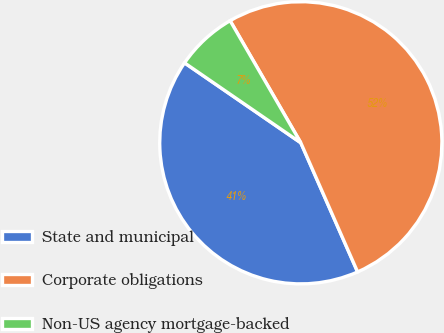Convert chart to OTSL. <chart><loc_0><loc_0><loc_500><loc_500><pie_chart><fcel>State and municipal<fcel>Corporate obligations<fcel>Non-US agency mortgage-backed<nl><fcel>41.18%<fcel>51.76%<fcel>7.06%<nl></chart> 